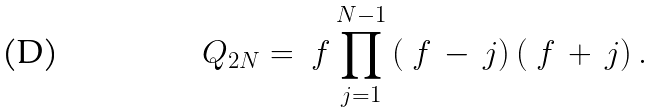Convert formula to latex. <formula><loc_0><loc_0><loc_500><loc_500>Q _ { 2 N } = \ f \prod _ { j = 1 } ^ { N - 1 } \left ( \ f \, - \, j \right ) \left ( \ f \, + \, j \right ) .</formula> 